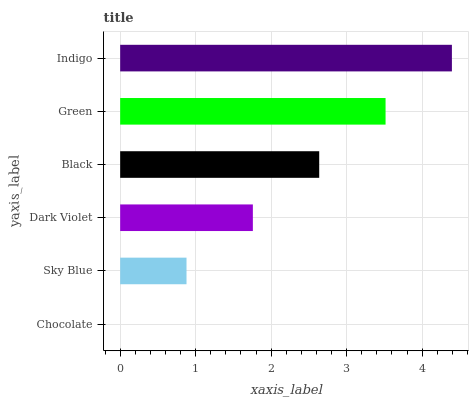Is Chocolate the minimum?
Answer yes or no. Yes. Is Indigo the maximum?
Answer yes or no. Yes. Is Sky Blue the minimum?
Answer yes or no. No. Is Sky Blue the maximum?
Answer yes or no. No. Is Sky Blue greater than Chocolate?
Answer yes or no. Yes. Is Chocolate less than Sky Blue?
Answer yes or no. Yes. Is Chocolate greater than Sky Blue?
Answer yes or no. No. Is Sky Blue less than Chocolate?
Answer yes or no. No. Is Black the high median?
Answer yes or no. Yes. Is Dark Violet the low median?
Answer yes or no. Yes. Is Chocolate the high median?
Answer yes or no. No. Is Sky Blue the low median?
Answer yes or no. No. 